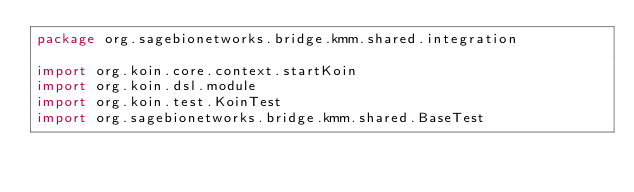Convert code to text. <code><loc_0><loc_0><loc_500><loc_500><_Kotlin_>package org.sagebionetworks.bridge.kmm.shared.integration

import org.koin.core.context.startKoin
import org.koin.dsl.module
import org.koin.test.KoinTest
import org.sagebionetworks.bridge.kmm.shared.BaseTest</code> 